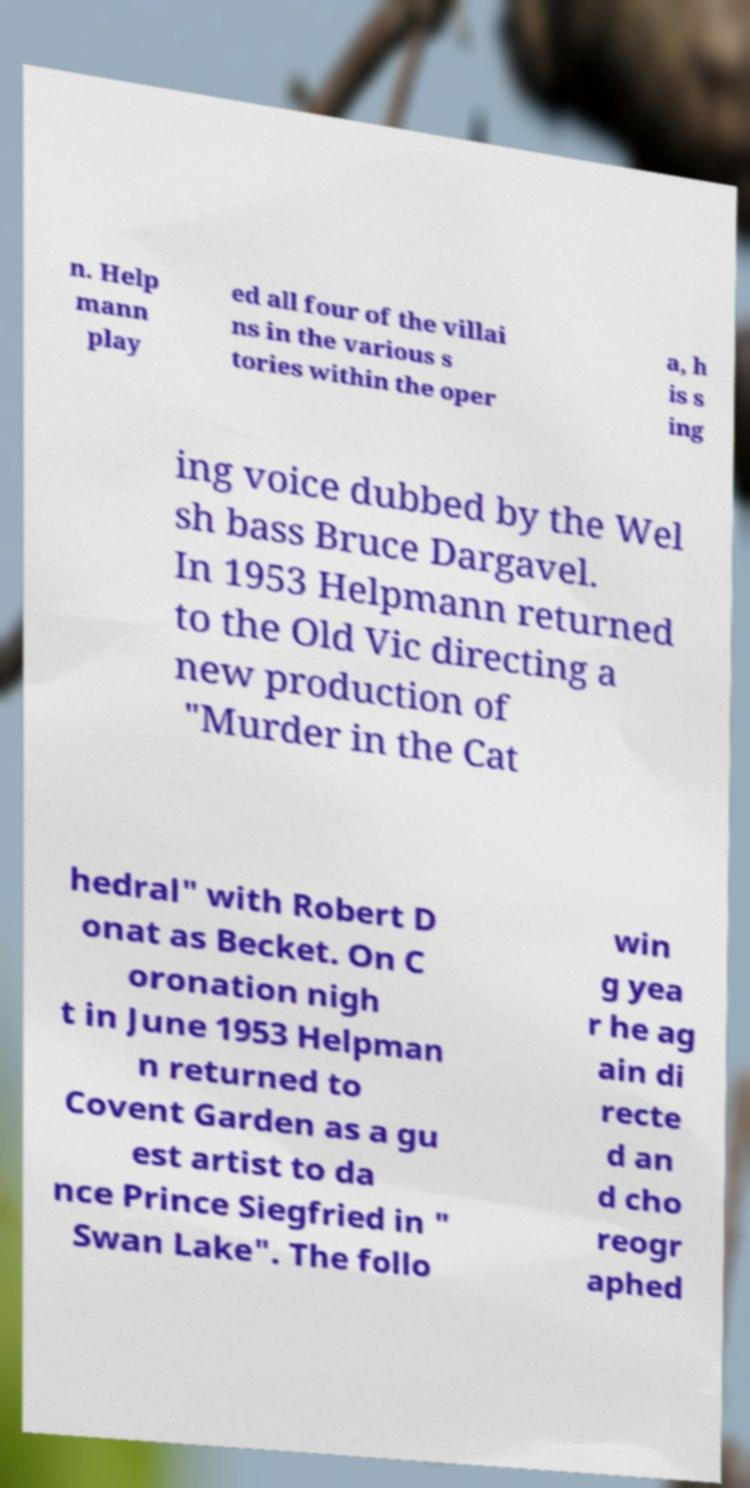Can you read and provide the text displayed in the image?This photo seems to have some interesting text. Can you extract and type it out for me? n. Help mann play ed all four of the villai ns in the various s tories within the oper a, h is s ing ing voice dubbed by the Wel sh bass Bruce Dargavel. In 1953 Helpmann returned to the Old Vic directing a new production of "Murder in the Cat hedral" with Robert D onat as Becket. On C oronation nigh t in June 1953 Helpman n returned to Covent Garden as a gu est artist to da nce Prince Siegfried in " Swan Lake". The follo win g yea r he ag ain di recte d an d cho reogr aphed 